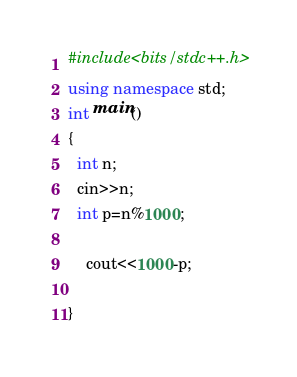<code> <loc_0><loc_0><loc_500><loc_500><_C++_>#include<bits/stdc++.h>
using namespace std;
int main()
{
  int n;
  cin>>n;
  int p=n%1000;
  
    cout<<1000-p;
  
}</code> 